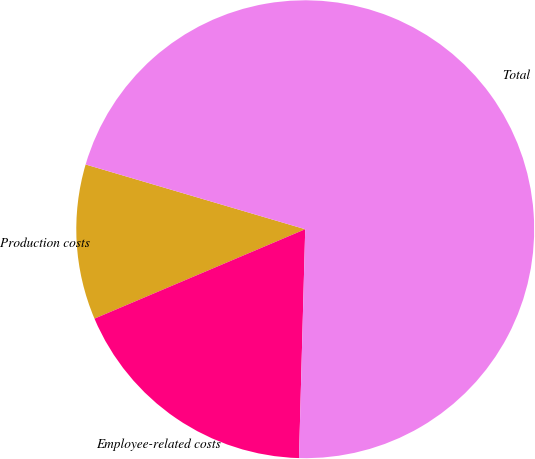<chart> <loc_0><loc_0><loc_500><loc_500><pie_chart><fcel>Production costs<fcel>Employee-related costs<fcel>Total<nl><fcel>10.95%<fcel>18.18%<fcel>70.87%<nl></chart> 